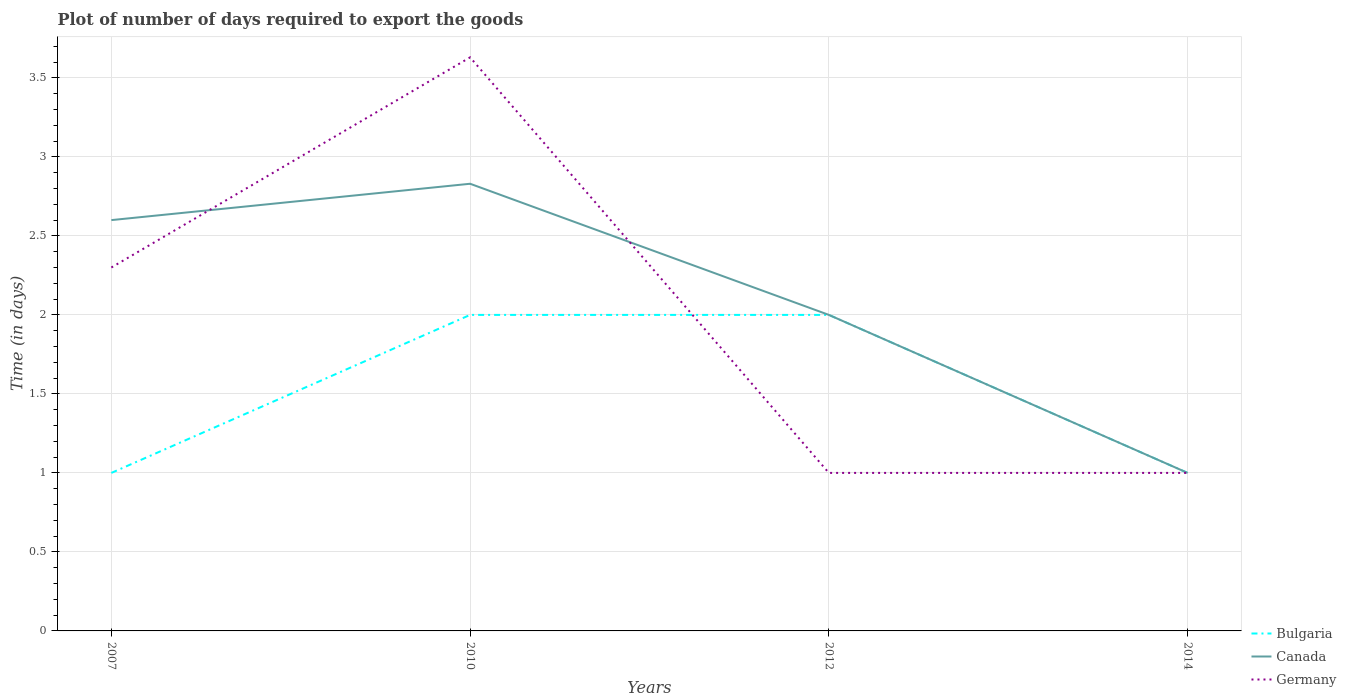Does the line corresponding to Canada intersect with the line corresponding to Bulgaria?
Provide a short and direct response. Yes. What is the total time required to export goods in Canada in the graph?
Keep it short and to the point. -0.23. What is the difference between the highest and the second highest time required to export goods in Germany?
Offer a terse response. 2.63. What is the difference between the highest and the lowest time required to export goods in Bulgaria?
Your answer should be very brief. 2. How many lines are there?
Give a very brief answer. 3. How many years are there in the graph?
Provide a short and direct response. 4. Are the values on the major ticks of Y-axis written in scientific E-notation?
Offer a very short reply. No. Does the graph contain any zero values?
Provide a short and direct response. No. Does the graph contain grids?
Offer a terse response. Yes. What is the title of the graph?
Your answer should be compact. Plot of number of days required to export the goods. What is the label or title of the X-axis?
Make the answer very short. Years. What is the label or title of the Y-axis?
Offer a very short reply. Time (in days). What is the Time (in days) in Bulgaria in 2007?
Your response must be concise. 1. What is the Time (in days) in Canada in 2007?
Your answer should be very brief. 2.6. What is the Time (in days) of Bulgaria in 2010?
Make the answer very short. 2. What is the Time (in days) of Canada in 2010?
Offer a very short reply. 2.83. What is the Time (in days) in Germany in 2010?
Make the answer very short. 3.63. What is the Time (in days) of Bulgaria in 2012?
Ensure brevity in your answer.  2. Across all years, what is the maximum Time (in days) of Bulgaria?
Keep it short and to the point. 2. Across all years, what is the maximum Time (in days) of Canada?
Provide a succinct answer. 2.83. Across all years, what is the maximum Time (in days) in Germany?
Your answer should be very brief. 3.63. Across all years, what is the minimum Time (in days) of Bulgaria?
Give a very brief answer. 1. What is the total Time (in days) of Canada in the graph?
Your response must be concise. 8.43. What is the total Time (in days) of Germany in the graph?
Make the answer very short. 7.93. What is the difference between the Time (in days) in Bulgaria in 2007 and that in 2010?
Your response must be concise. -1. What is the difference between the Time (in days) of Canada in 2007 and that in 2010?
Give a very brief answer. -0.23. What is the difference between the Time (in days) of Germany in 2007 and that in 2010?
Ensure brevity in your answer.  -1.33. What is the difference between the Time (in days) of Canada in 2007 and that in 2012?
Keep it short and to the point. 0.6. What is the difference between the Time (in days) in Germany in 2007 and that in 2012?
Make the answer very short. 1.3. What is the difference between the Time (in days) of Canada in 2007 and that in 2014?
Provide a succinct answer. 1.6. What is the difference between the Time (in days) of Bulgaria in 2010 and that in 2012?
Ensure brevity in your answer.  0. What is the difference between the Time (in days) in Canada in 2010 and that in 2012?
Give a very brief answer. 0.83. What is the difference between the Time (in days) of Germany in 2010 and that in 2012?
Your answer should be compact. 2.63. What is the difference between the Time (in days) of Canada in 2010 and that in 2014?
Ensure brevity in your answer.  1.83. What is the difference between the Time (in days) in Germany in 2010 and that in 2014?
Keep it short and to the point. 2.63. What is the difference between the Time (in days) in Germany in 2012 and that in 2014?
Ensure brevity in your answer.  0. What is the difference between the Time (in days) in Bulgaria in 2007 and the Time (in days) in Canada in 2010?
Provide a short and direct response. -1.83. What is the difference between the Time (in days) of Bulgaria in 2007 and the Time (in days) of Germany in 2010?
Give a very brief answer. -2.63. What is the difference between the Time (in days) in Canada in 2007 and the Time (in days) in Germany in 2010?
Offer a very short reply. -1.03. What is the difference between the Time (in days) of Bulgaria in 2007 and the Time (in days) of Germany in 2014?
Give a very brief answer. 0. What is the difference between the Time (in days) of Bulgaria in 2010 and the Time (in days) of Canada in 2012?
Provide a succinct answer. 0. What is the difference between the Time (in days) in Bulgaria in 2010 and the Time (in days) in Germany in 2012?
Ensure brevity in your answer.  1. What is the difference between the Time (in days) of Canada in 2010 and the Time (in days) of Germany in 2012?
Make the answer very short. 1.83. What is the difference between the Time (in days) in Bulgaria in 2010 and the Time (in days) in Canada in 2014?
Offer a very short reply. 1. What is the difference between the Time (in days) of Canada in 2010 and the Time (in days) of Germany in 2014?
Provide a succinct answer. 1.83. What is the difference between the Time (in days) of Bulgaria in 2012 and the Time (in days) of Germany in 2014?
Make the answer very short. 1. What is the average Time (in days) in Canada per year?
Keep it short and to the point. 2.11. What is the average Time (in days) in Germany per year?
Offer a very short reply. 1.98. In the year 2007, what is the difference between the Time (in days) in Bulgaria and Time (in days) in Canada?
Your answer should be very brief. -1.6. In the year 2010, what is the difference between the Time (in days) of Bulgaria and Time (in days) of Canada?
Offer a very short reply. -0.83. In the year 2010, what is the difference between the Time (in days) of Bulgaria and Time (in days) of Germany?
Make the answer very short. -1.63. In the year 2012, what is the difference between the Time (in days) of Bulgaria and Time (in days) of Germany?
Ensure brevity in your answer.  1. What is the ratio of the Time (in days) of Bulgaria in 2007 to that in 2010?
Ensure brevity in your answer.  0.5. What is the ratio of the Time (in days) in Canada in 2007 to that in 2010?
Provide a succinct answer. 0.92. What is the ratio of the Time (in days) of Germany in 2007 to that in 2010?
Your response must be concise. 0.63. What is the ratio of the Time (in days) in Bulgaria in 2007 to that in 2012?
Your answer should be compact. 0.5. What is the ratio of the Time (in days) in Germany in 2007 to that in 2012?
Offer a very short reply. 2.3. What is the ratio of the Time (in days) in Canada in 2007 to that in 2014?
Provide a short and direct response. 2.6. What is the ratio of the Time (in days) in Germany in 2007 to that in 2014?
Your answer should be very brief. 2.3. What is the ratio of the Time (in days) in Bulgaria in 2010 to that in 2012?
Your response must be concise. 1. What is the ratio of the Time (in days) of Canada in 2010 to that in 2012?
Provide a short and direct response. 1.42. What is the ratio of the Time (in days) of Germany in 2010 to that in 2012?
Keep it short and to the point. 3.63. What is the ratio of the Time (in days) in Bulgaria in 2010 to that in 2014?
Keep it short and to the point. 2. What is the ratio of the Time (in days) of Canada in 2010 to that in 2014?
Keep it short and to the point. 2.83. What is the ratio of the Time (in days) of Germany in 2010 to that in 2014?
Make the answer very short. 3.63. What is the ratio of the Time (in days) of Canada in 2012 to that in 2014?
Ensure brevity in your answer.  2. What is the ratio of the Time (in days) in Germany in 2012 to that in 2014?
Ensure brevity in your answer.  1. What is the difference between the highest and the second highest Time (in days) of Bulgaria?
Keep it short and to the point. 0. What is the difference between the highest and the second highest Time (in days) in Canada?
Keep it short and to the point. 0.23. What is the difference between the highest and the second highest Time (in days) in Germany?
Give a very brief answer. 1.33. What is the difference between the highest and the lowest Time (in days) in Bulgaria?
Your answer should be compact. 1. What is the difference between the highest and the lowest Time (in days) in Canada?
Offer a terse response. 1.83. What is the difference between the highest and the lowest Time (in days) in Germany?
Provide a short and direct response. 2.63. 